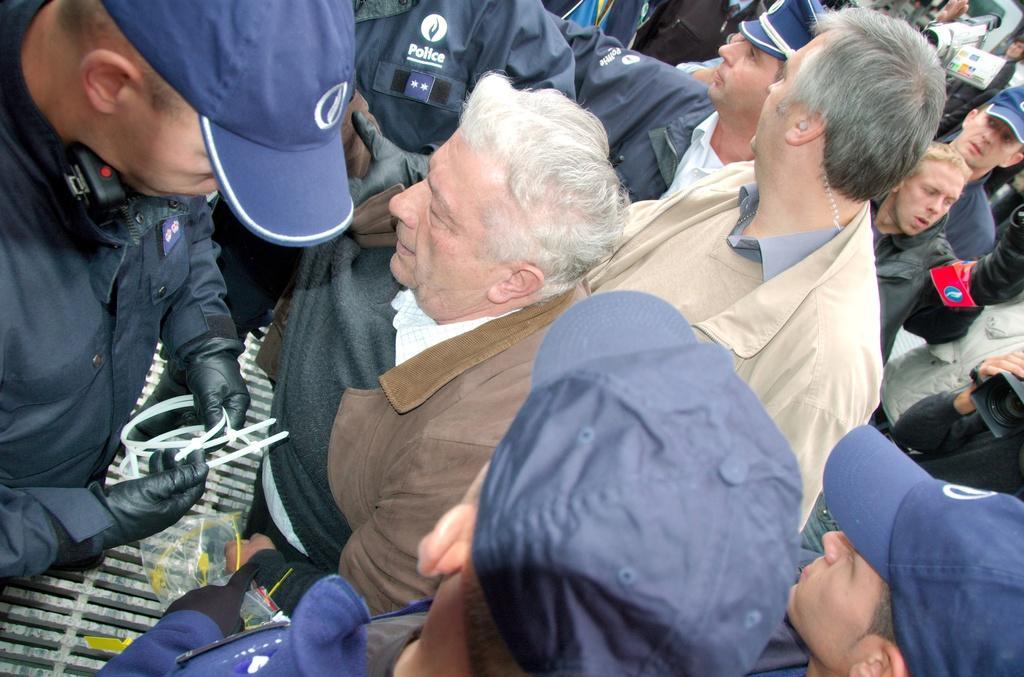Can you describe this image briefly? In this image I can see number of people where I can see most of them are wearing jackets and few of them are wearing caps. I can also see few cameras over here. 